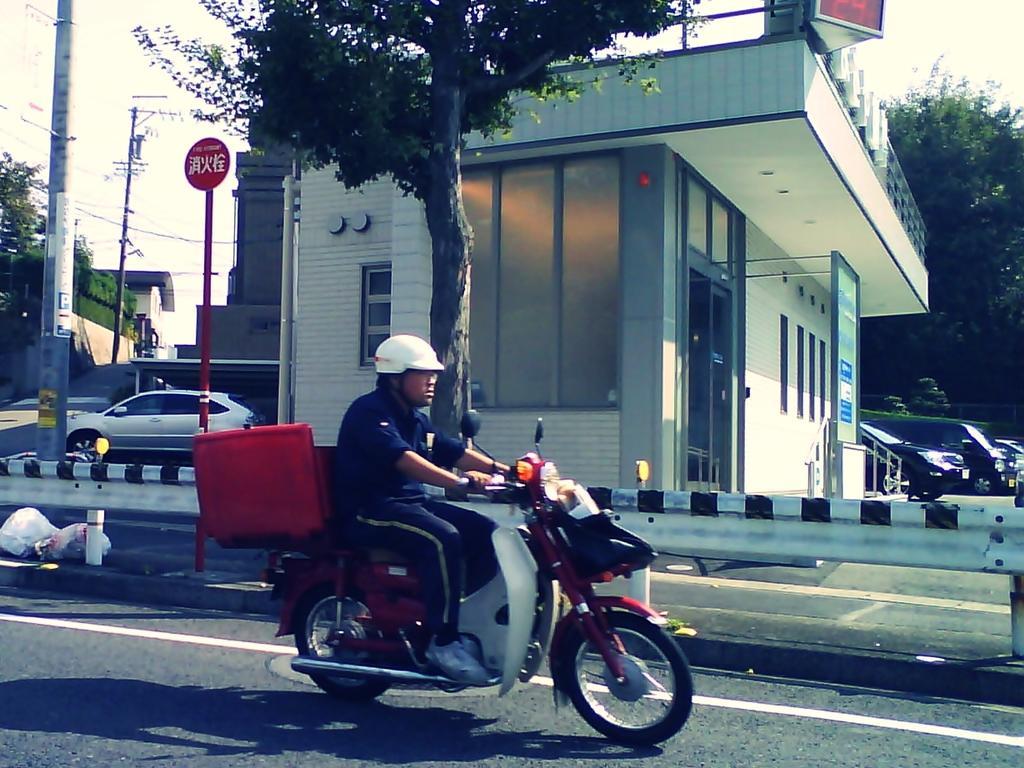Can you describe this image briefly? In the picture we can see a person wearing blue color dress, white color shoes, helmet, riding motorcycle on road, in the background there are some houses, trees, boards, poles, vehicles which are parked. 